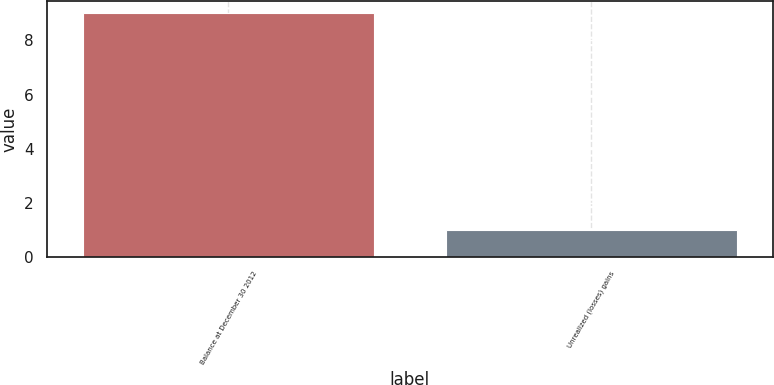Convert chart. <chart><loc_0><loc_0><loc_500><loc_500><bar_chart><fcel>Balance at December 30 2012<fcel>Unrealized (losses) gains<nl><fcel>9<fcel>1<nl></chart> 